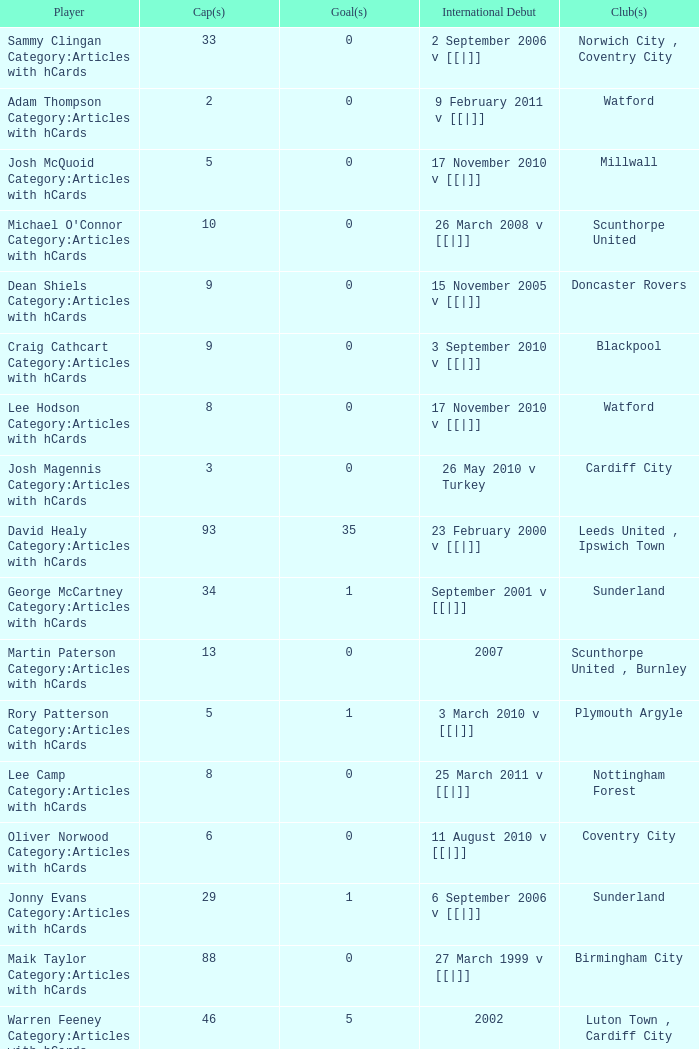How many caps figures for the Doncaster Rovers? 1.0. 